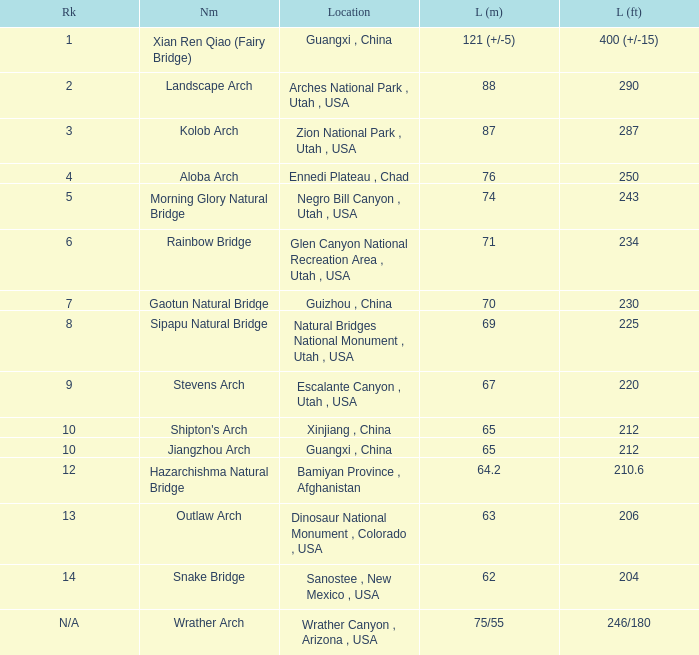What is the measurement in feet when the measurement in meters is 6 210.6. 